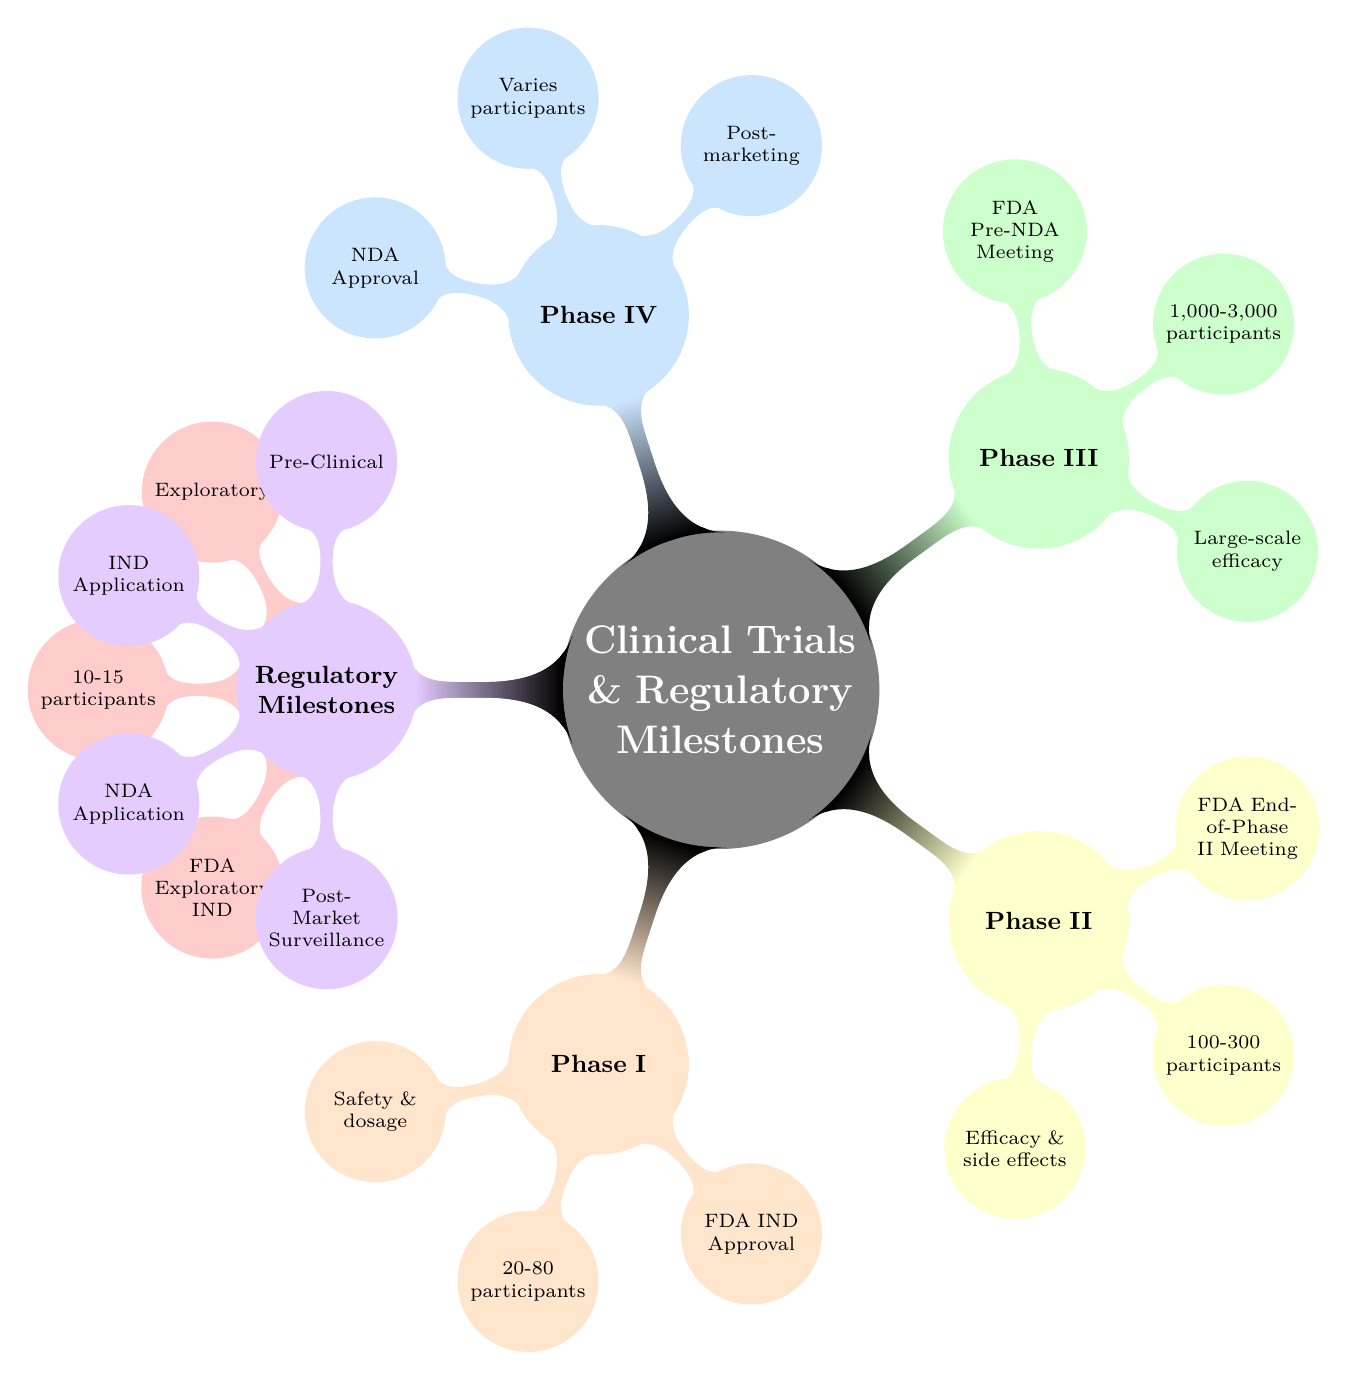What is the participant range for Phase II? The diagram specifies that Phase II has a participant range of 100 to 300. This information can be found directly under the Phase II node, which highlights the number of participants involved in this stage of clinical trials.
Answer: 100-300 What regulatory milestone is associated with Phase III? The Phase III node specifically indicates that the regulatory milestone for this stage is the FDA Pre-NDA Meeting. This is noted as a key event in the approval process, showcasing its importance.
Answer: FDA Pre-NDA Meeting How many phases of clinical trials are detailed in the diagram? By counting the distinct child nodes under the Clinical Trials root, there are five phases listed: Phase 0, Phase I, Phase II, Phase III, and Phase IV. This total indicates the progression of trials before reaching market status.
Answer: 5 What is one of the goals of Phase I trials? The diagram mentions that one of the goals of Phase I trials is to determine the safe dosage range. This reflects the focus on safety during this early stage of clinical testing.
Answer: Determine safe dosage range Which phase focuses on post-marketing surveillance? According to the diagram, Phase IV is the stage that emphasizes post-marketing surveillance. It gathers information on the drug's long-term effects after it has been approved for use.
Answer: Phase IV What outcome is expected from the IND Application? The diagram shows that the outcome of the IND Application is to allow human trials to start. This is a crucial step in the clinical trial process, enabling progression beyond pre-clinical testing.
Answer: Allows human trials to start What type of data is included in the NDA Application? The diagram states that the NDA Application includes clinical trial data, clinical pharmacology data, and labeling information. This comprehensive data is necessary for obtaining market approval.
Answer: Clinical trial data, clinical pharmacology data, labeling information Which phase has the largest participant range? By analyzing the participant ranges listed, Phase III has the largest range, with participants ranging from 1,000 to 3,000. This indicates a significant investment in testing efficacy at this later stage.
Answer: 1,000-3,000 What is the focus of the Pre-Clinical regulatory milestone? The Pre-Clinical milestone is centered on laboratory and animal testing, as indicated in the diagram. This initial phase is critical for assessing safety before human trials begin.
Answer: Laboratory and animal testing 